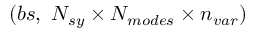Convert formula to latex. <formula><loc_0><loc_0><loc_500><loc_500>( b s , \ N _ { s y } \times N _ { m o d e s } \times n _ { v a r } )</formula> 